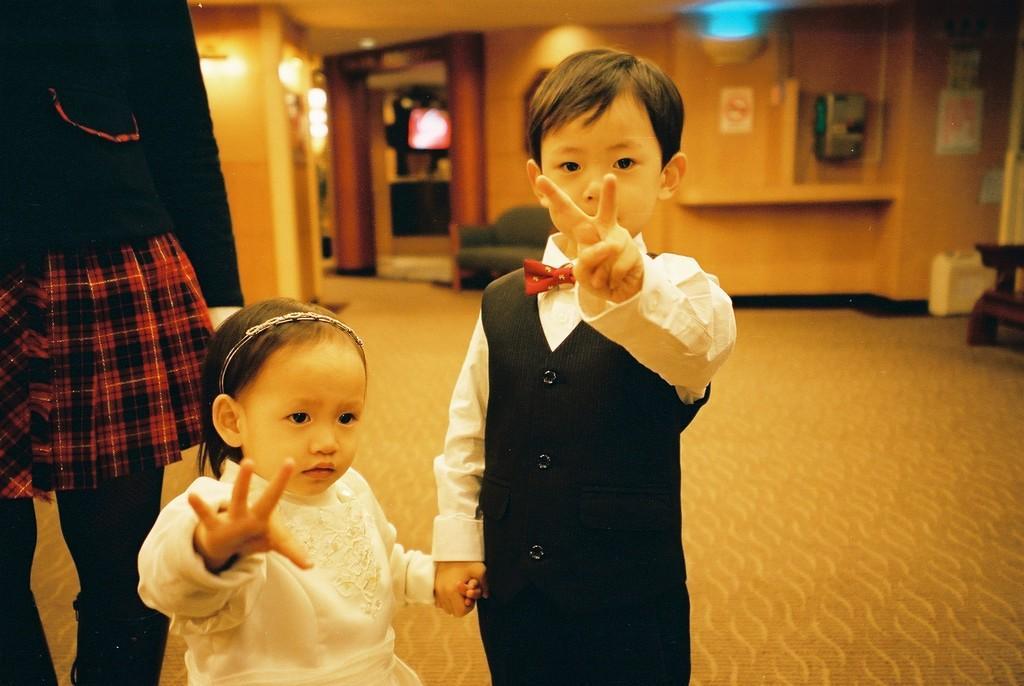Describe this image in one or two sentences. In this image I can see three people with black, red and white color dresses. In the background I can see the couch, many boards to the wall and the lights. To the right I can see the some objects. 